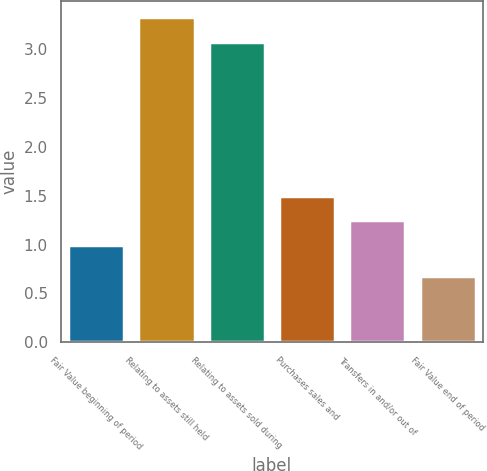Convert chart. <chart><loc_0><loc_0><loc_500><loc_500><bar_chart><fcel>Fair Value beginning of period<fcel>Relating to assets still held<fcel>Relating to assets sold during<fcel>Purchases sales and<fcel>Transfers in and/or out of<fcel>Fair Value end of period<nl><fcel>1<fcel>3.33<fcel>3.08<fcel>1.5<fcel>1.25<fcel>0.68<nl></chart> 